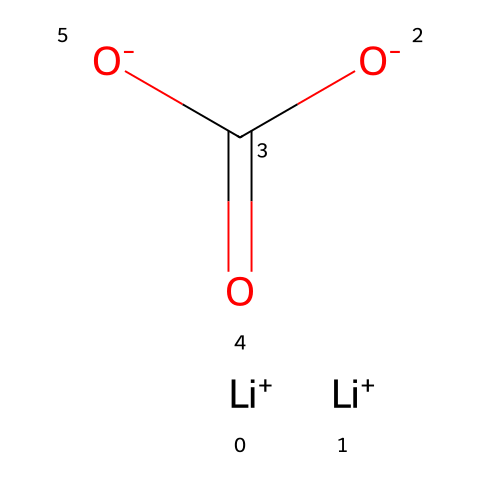What is the name of this chemical? The SMILES representation indicates a compound with lithium and carbonate components. By analyzing this, we can conclude it's lithium carbonate, commonly used for treating bipolar disorder.
Answer: lithium carbonate How many lithium atoms are present in this molecule? By looking at the SMILES, we can see two instances of [Li+], indicating there are two lithium atoms in the structure.
Answer: 2 What is the total number of oxygen atoms in this molecule? The SMILES shows two instances of [O-] and one carbonyl oxygen (=O), totaling three oxygen atoms in the molecular structure.
Answer: 3 What type of bond connects the lithium ions to the carbonate group? The lithium ions are positively charged and attract the negatively charged carbonate group, forming ionic bonds between them.
Answer: ionic How does the structure of lithium carbonate contribute to its medicinal use? Lithium carbonate’s ionic nature allows it to dissolve in bodily fluids, enabling it to effectively alter neurotransmitter activities, which is essential for treating mood disorders.
Answer: alters neurotransmitter activities What functional groups are present in lithium carbonate? The structure contains a carbonate group (which includes the carbonyl and oxygen atoms), and as it interacts with lithium ions, this makes it a medicinal compound.
Answer: carbonate group Which ion is responsible for the compound's therapeutic properties? The lithium ion has been identified as the primary ion responsible for the compound's therapeutic effects in bipolar disorder treatment by modulating mood.
Answer: lithium ion 